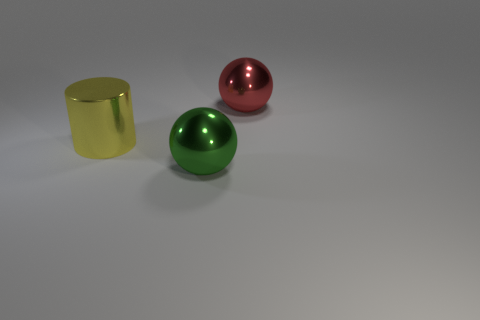Add 1 red shiny balls. How many objects exist? 4 Subtract 1 balls. How many balls are left? 1 Subtract all cylinders. How many objects are left? 2 Subtract all brown spheres. Subtract all gray cylinders. How many spheres are left? 2 Subtract 0 blue cylinders. How many objects are left? 3 Subtract all large metallic blocks. Subtract all big yellow cylinders. How many objects are left? 2 Add 1 big yellow metallic things. How many big yellow metallic things are left? 2 Add 1 large blue metallic cylinders. How many large blue metallic cylinders exist? 1 